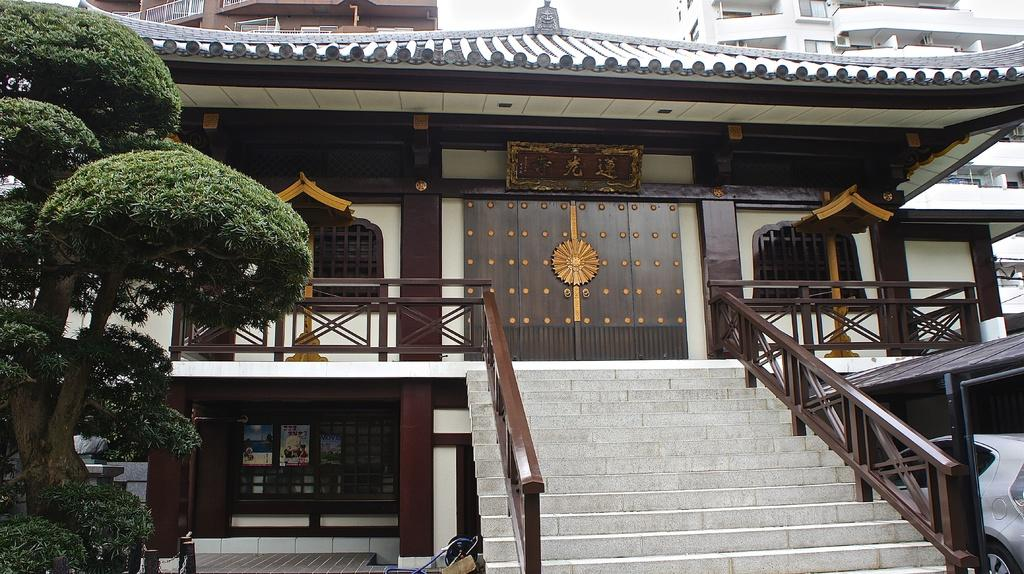What type of vegetation can be seen in the image? There are trees in the image. What is the color of the trees? The trees are green. What structures are visible in the background of the image? There are buildings in the background of the image. What colors are the buildings? The buildings are in brown and white colors. What part of the natural environment is visible in the image? The sky is visible in the image. What is the color of the sky? The sky is white. Can you see a hose being used by a monkey in the image? There is no hose or monkey present in the image. How many worms are crawling on the trees in the image? There are no worms visible on the trees in the image. 